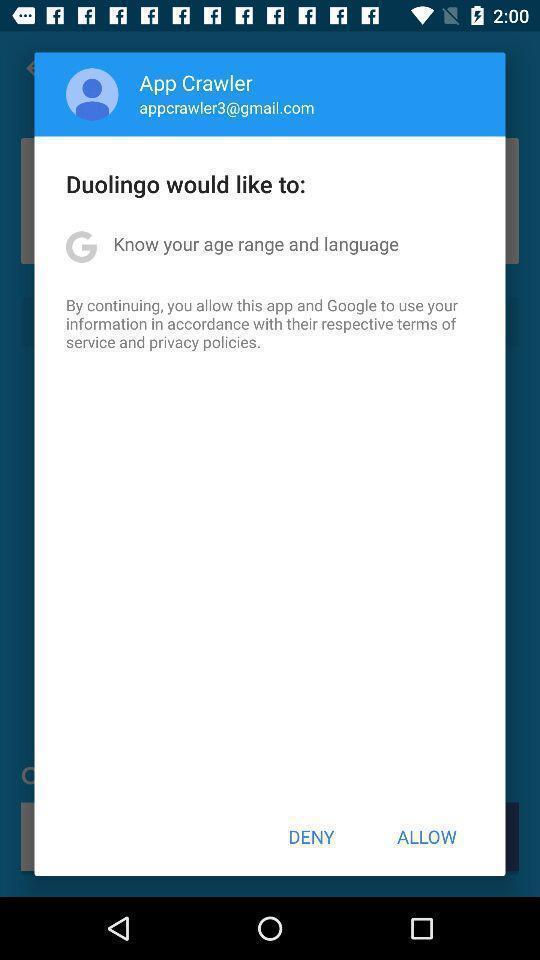Summarize the main components in this picture. Popup of the notification to give the agree nod. 